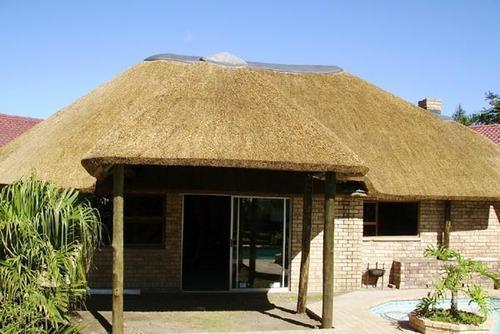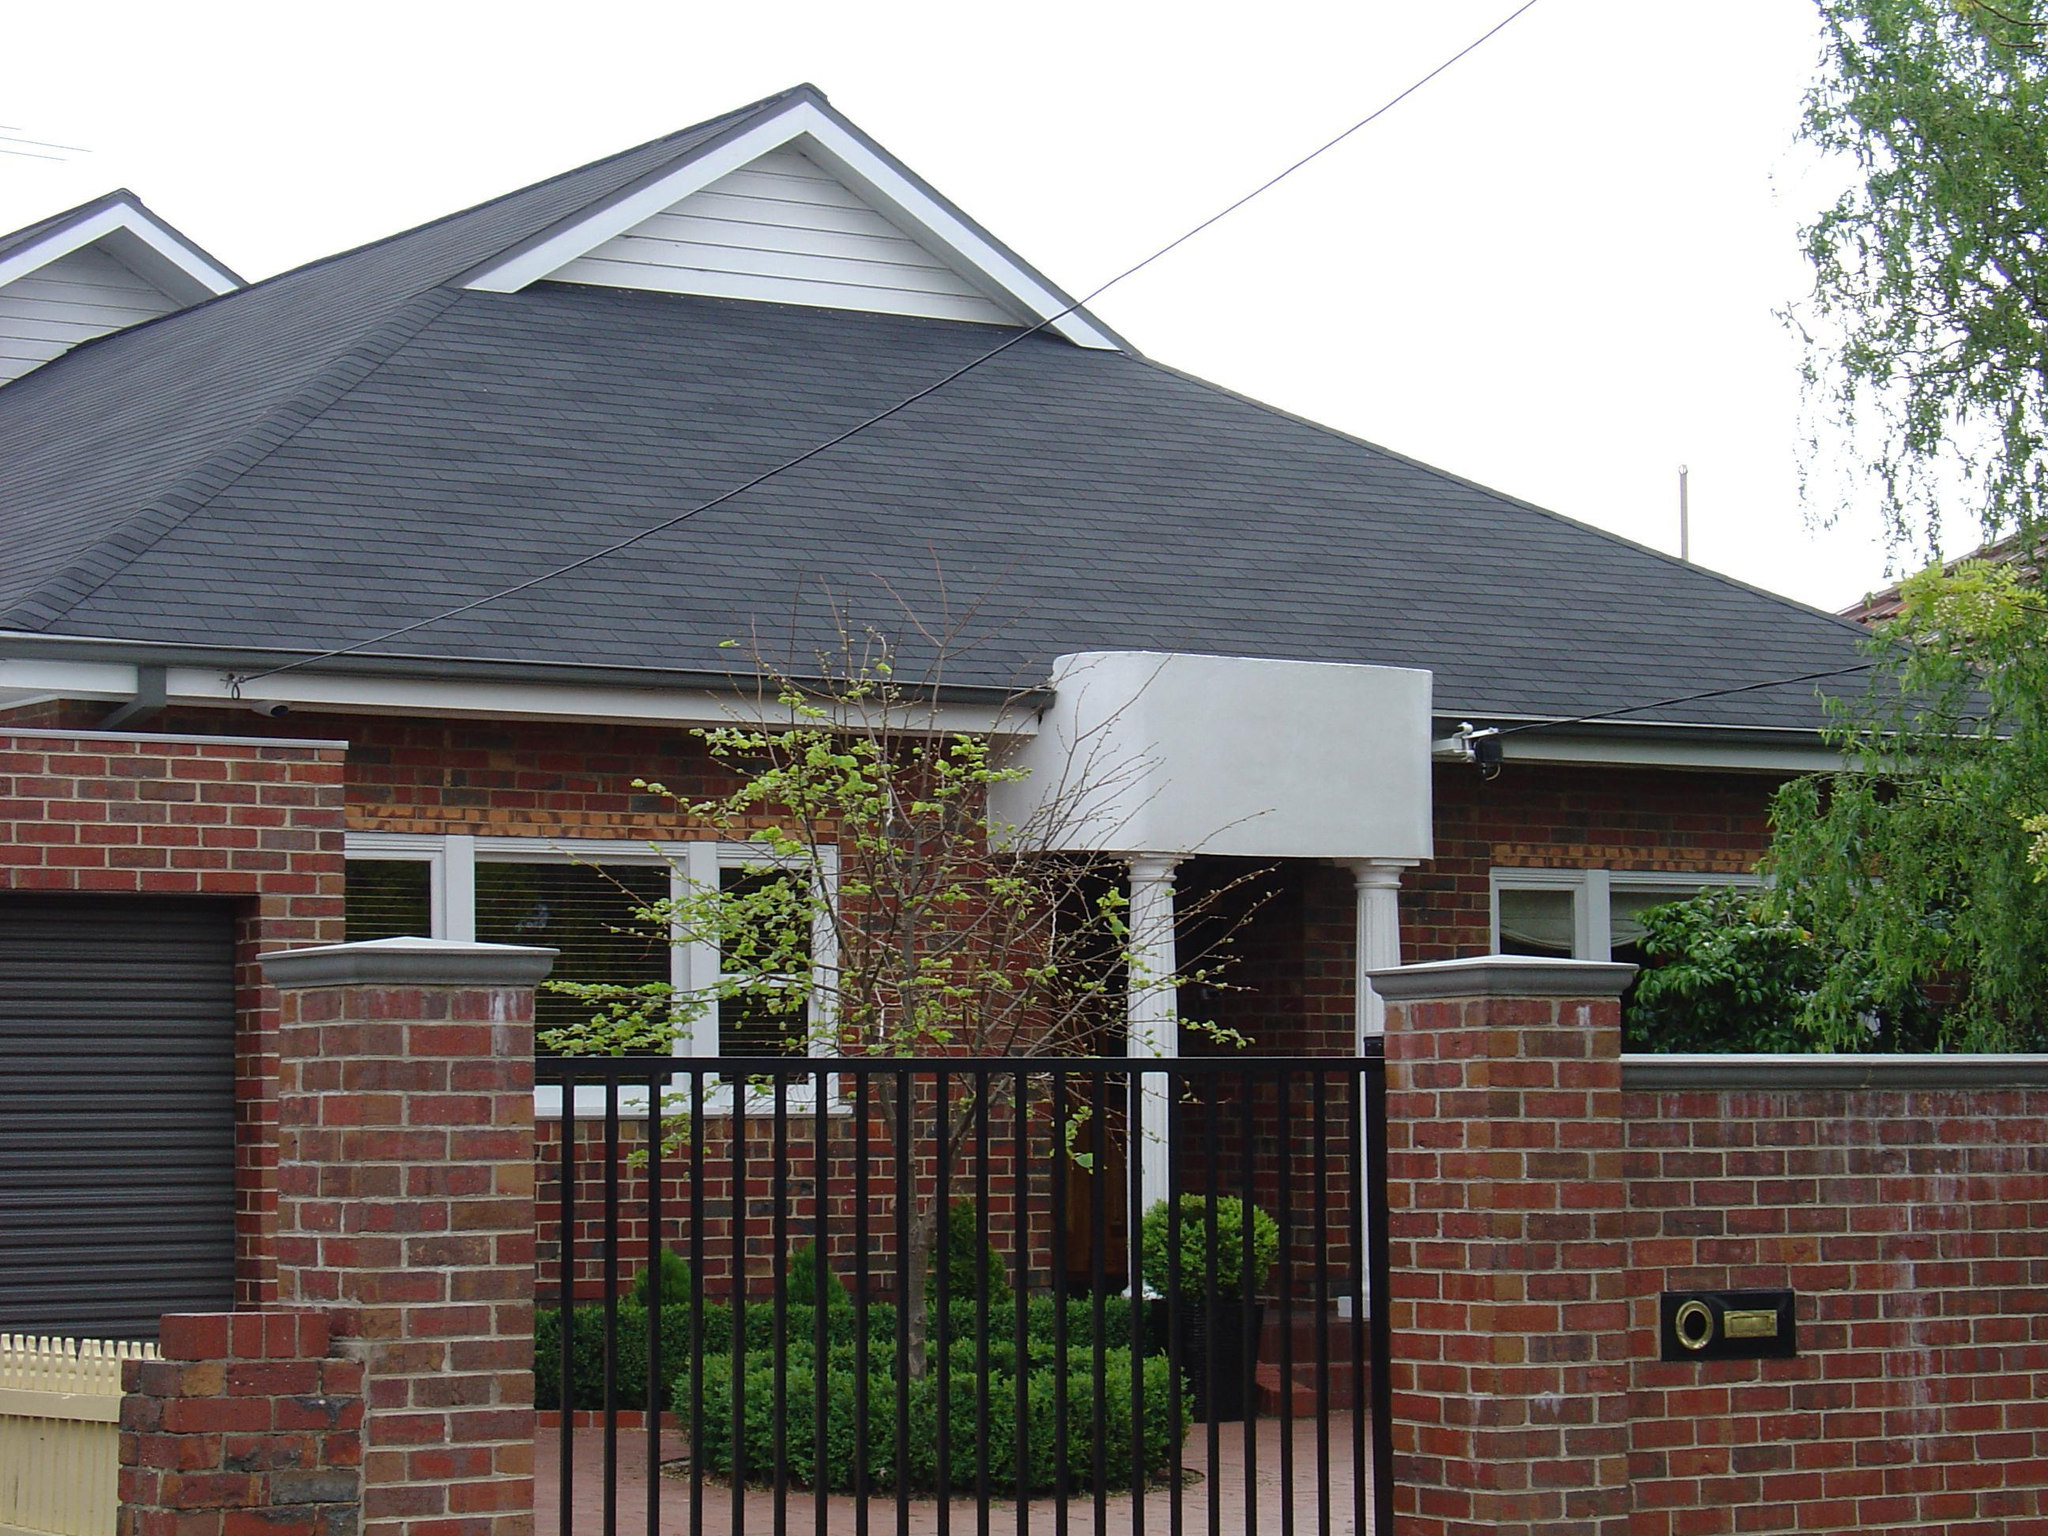The first image is the image on the left, the second image is the image on the right. For the images displayed, is the sentence "The left image includes a peaked thatch roof with an even bottom edge and a gray cap on its tip, held up by corner posts." factually correct? Answer yes or no. Yes. 